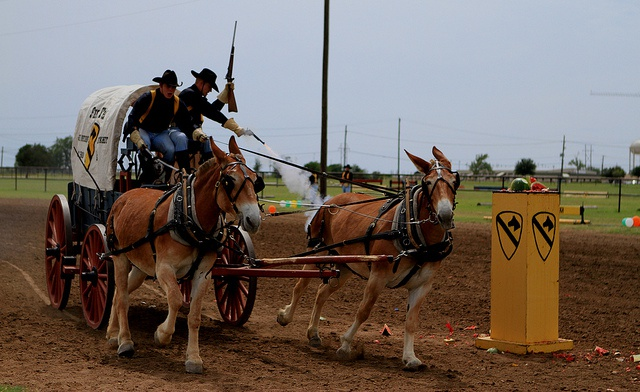Describe the objects in this image and their specific colors. I can see horse in darkgray, black, maroon, and gray tones, horse in darkgray, black, maroon, and gray tones, people in darkgray, black, maroon, gray, and navy tones, people in darkgray, black, maroon, and gray tones, and people in darkgray, black, gray, and maroon tones in this image. 